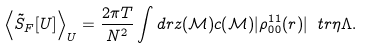<formula> <loc_0><loc_0><loc_500><loc_500>\left \langle \tilde { S } _ { F } [ U ] \right \rangle _ { U } = \frac { 2 \pi T } { N ^ { 2 } } \int d r z ( \mathcal { M } ) c ( \mathcal { M } ) | \rho _ { 0 0 } ^ { 1 1 } ( r ) | \ t r \eta \Lambda .</formula> 